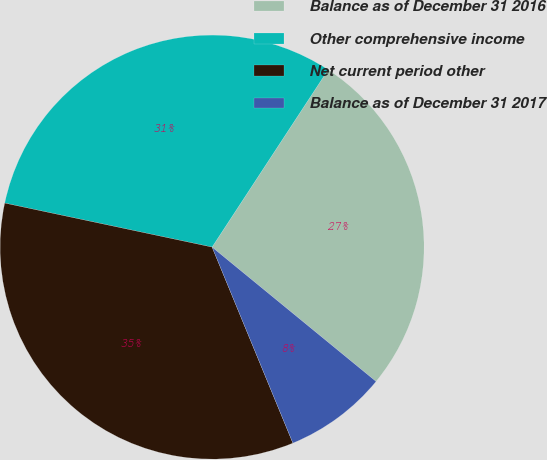Convert chart. <chart><loc_0><loc_0><loc_500><loc_500><pie_chart><fcel>Balance as of December 31 2016<fcel>Other comprehensive income<fcel>Net current period other<fcel>Balance as of December 31 2017<nl><fcel>26.7%<fcel>30.89%<fcel>34.55%<fcel>7.85%<nl></chart> 